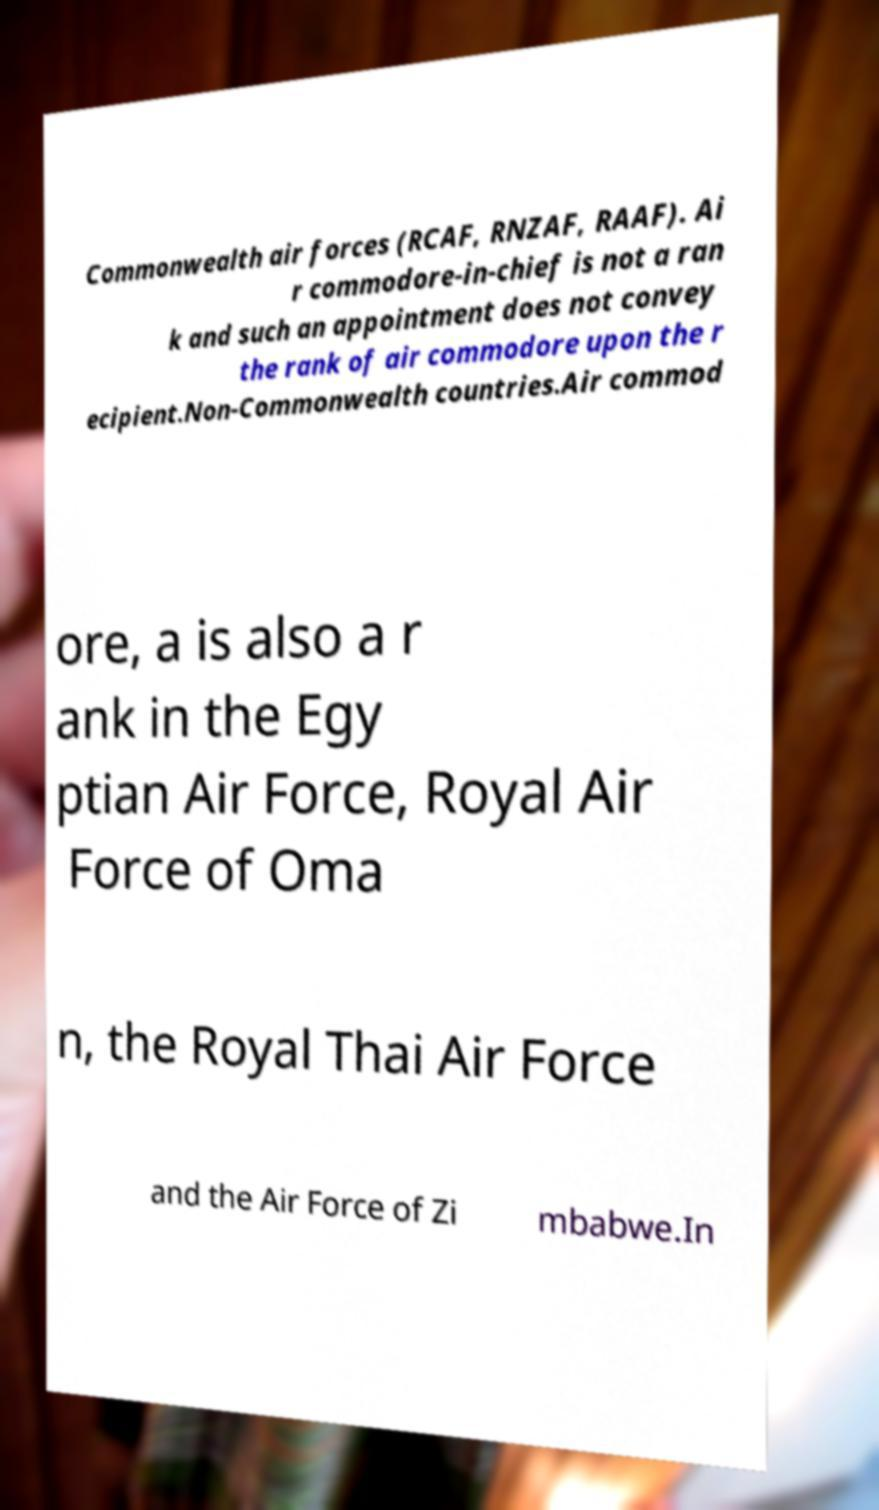Could you assist in decoding the text presented in this image and type it out clearly? Commonwealth air forces (RCAF, RNZAF, RAAF). Ai r commodore-in-chief is not a ran k and such an appointment does not convey the rank of air commodore upon the r ecipient.Non-Commonwealth countries.Air commod ore, a is also a r ank in the Egy ptian Air Force, Royal Air Force of Oma n, the Royal Thai Air Force and the Air Force of Zi mbabwe.In 